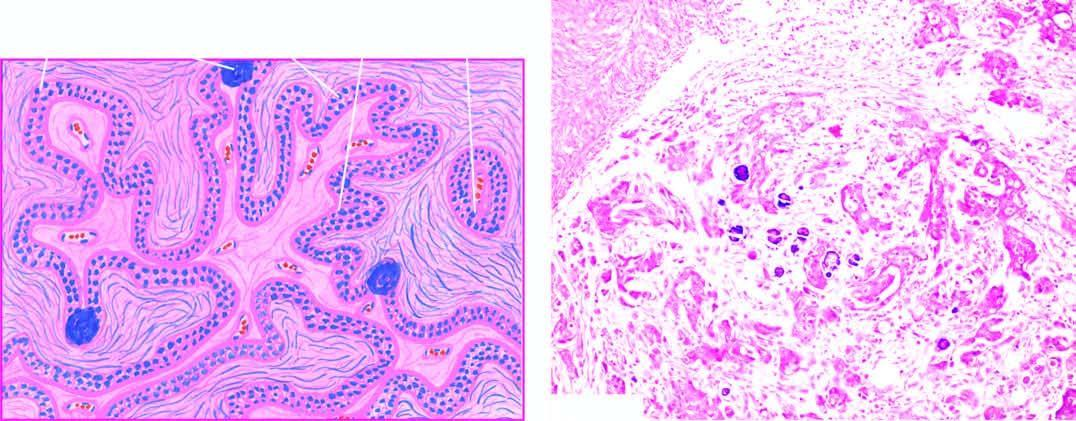how does the stroma show invasion?
Answer the question using a single word or phrase. By clusters of anaplastic tumour cells 